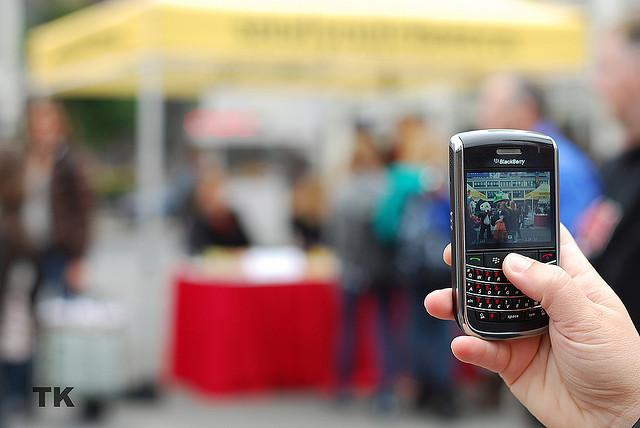Does the phone have a physical keyboard?
Answer briefly. Yes. Is the phone on?
Short answer required. Yes. What it the phone being used for?
Give a very brief answer. Picture. 